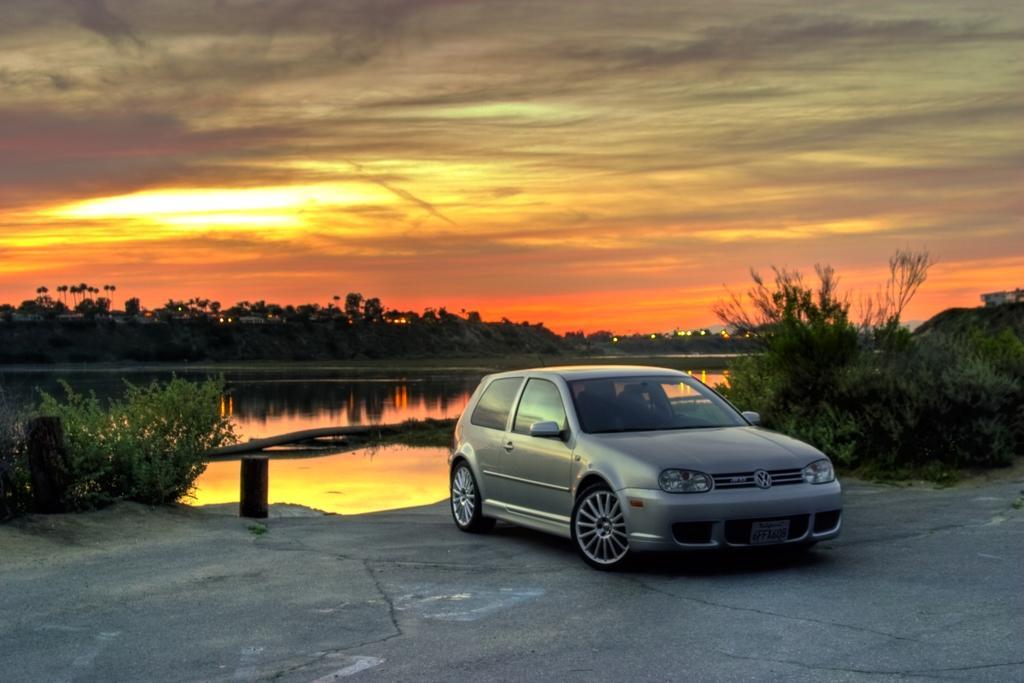In one or two sentences, can you explain what this image depicts? In this image there is a car in the middle. In the background there is water. Behind the water there are trees and houses. This image is clicked during the sunset. Beside the car there are plants on either side of it. 